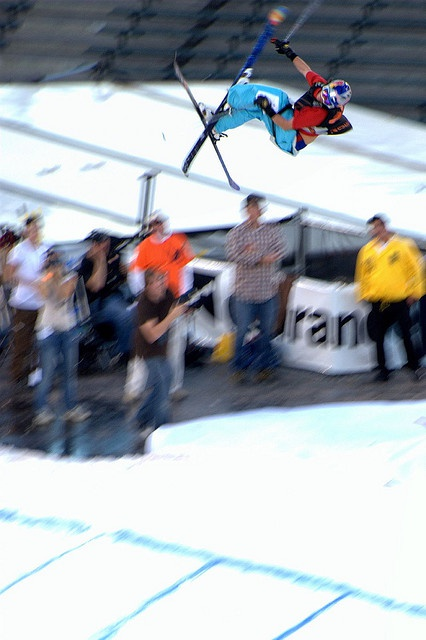Describe the objects in this image and their specific colors. I can see people in black, gray, and navy tones, people in black, orange, and gold tones, people in black, lightblue, and brown tones, people in black, red, darkgray, and gray tones, and people in black, gray, navy, darkblue, and darkgray tones in this image. 